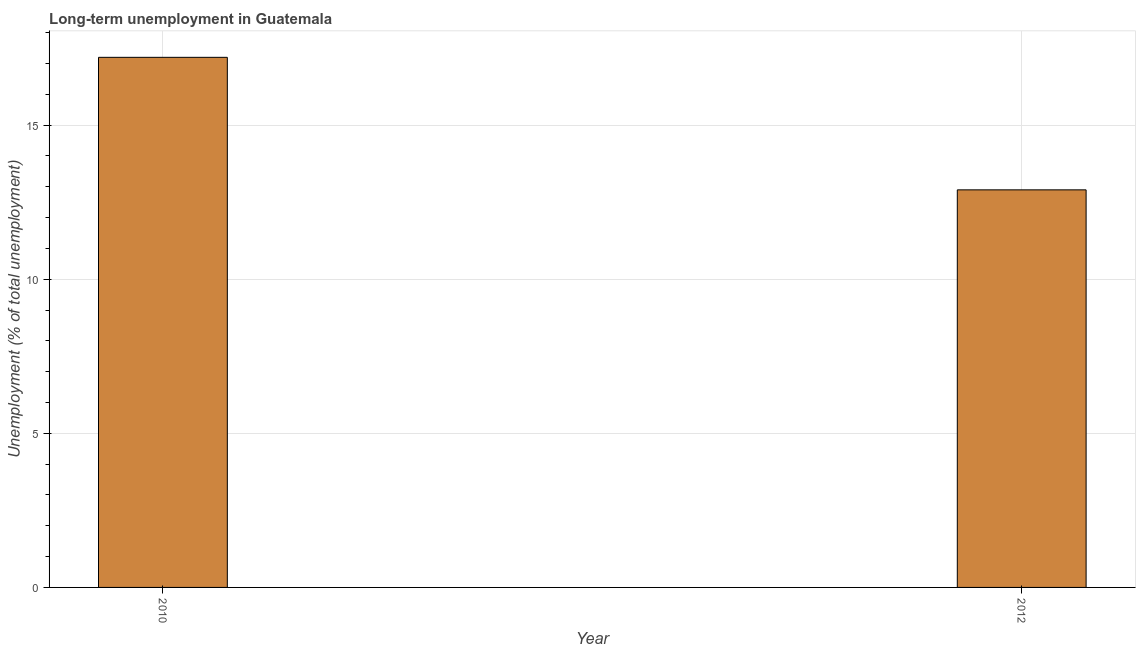Does the graph contain grids?
Offer a terse response. Yes. What is the title of the graph?
Your answer should be compact. Long-term unemployment in Guatemala. What is the label or title of the Y-axis?
Keep it short and to the point. Unemployment (% of total unemployment). What is the long-term unemployment in 2010?
Keep it short and to the point. 17.2. Across all years, what is the maximum long-term unemployment?
Your answer should be very brief. 17.2. Across all years, what is the minimum long-term unemployment?
Ensure brevity in your answer.  12.9. In which year was the long-term unemployment maximum?
Make the answer very short. 2010. What is the sum of the long-term unemployment?
Your answer should be compact. 30.1. What is the average long-term unemployment per year?
Offer a very short reply. 15.05. What is the median long-term unemployment?
Offer a very short reply. 15.05. What is the ratio of the long-term unemployment in 2010 to that in 2012?
Your answer should be very brief. 1.33. How many bars are there?
Your answer should be compact. 2. How many years are there in the graph?
Keep it short and to the point. 2. What is the difference between two consecutive major ticks on the Y-axis?
Your answer should be very brief. 5. What is the Unemployment (% of total unemployment) in 2010?
Your response must be concise. 17.2. What is the Unemployment (% of total unemployment) of 2012?
Offer a very short reply. 12.9. What is the difference between the Unemployment (% of total unemployment) in 2010 and 2012?
Offer a very short reply. 4.3. What is the ratio of the Unemployment (% of total unemployment) in 2010 to that in 2012?
Ensure brevity in your answer.  1.33. 